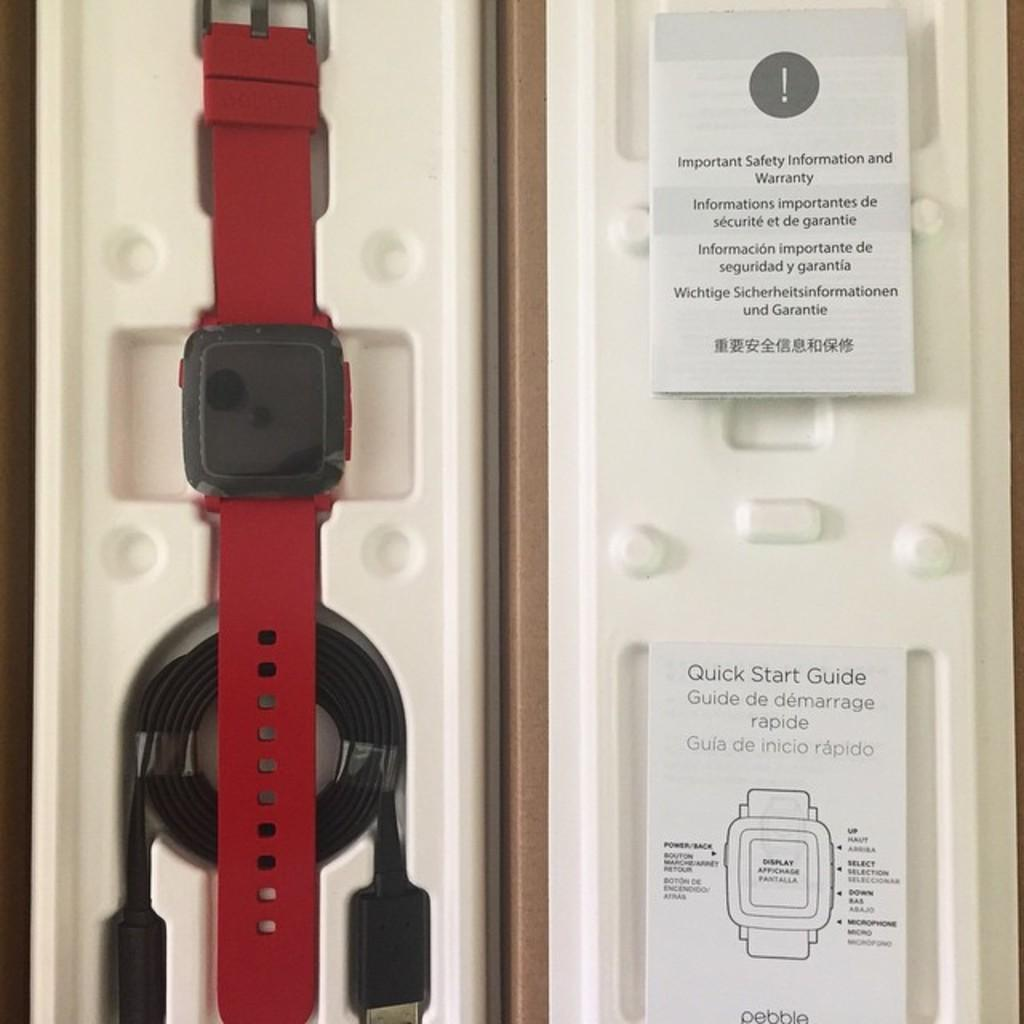Provide a one-sentence caption for the provided image. The new red watch has the instructions and a USB cable for charging. 